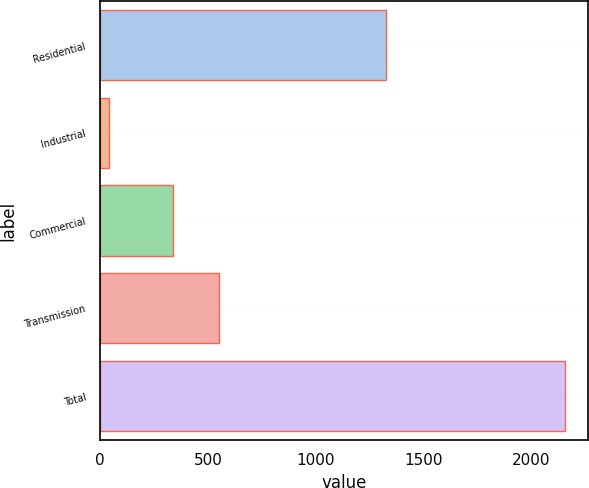Convert chart to OTSL. <chart><loc_0><loc_0><loc_500><loc_500><bar_chart><fcel>Residential<fcel>Industrial<fcel>Commercial<fcel>Transmission<fcel>Total<nl><fcel>1327<fcel>42<fcel>338<fcel>549.4<fcel>2156<nl></chart> 